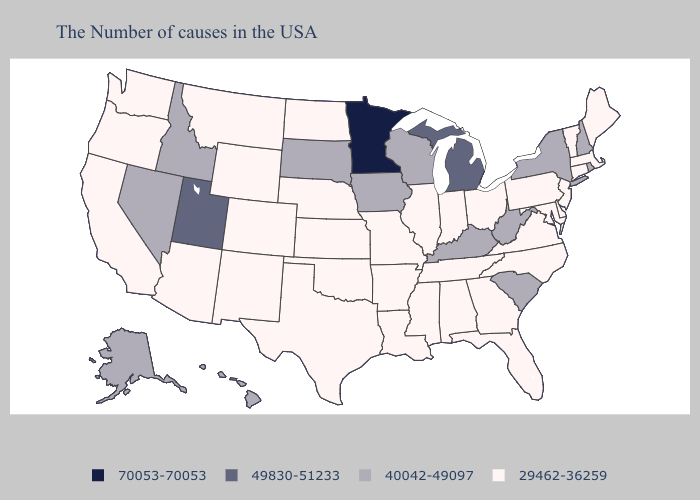Does Wisconsin have the lowest value in the MidWest?
Give a very brief answer. No. Name the states that have a value in the range 49830-51233?
Keep it brief. Michigan, Utah. Is the legend a continuous bar?
Short answer required. No. Which states hav the highest value in the MidWest?
Give a very brief answer. Minnesota. What is the value of Nebraska?
Answer briefly. 29462-36259. Which states have the highest value in the USA?
Quick response, please. Minnesota. What is the value of Colorado?
Short answer required. 29462-36259. Name the states that have a value in the range 29462-36259?
Short answer required. Maine, Massachusetts, Vermont, Connecticut, New Jersey, Delaware, Maryland, Pennsylvania, Virginia, North Carolina, Ohio, Florida, Georgia, Indiana, Alabama, Tennessee, Illinois, Mississippi, Louisiana, Missouri, Arkansas, Kansas, Nebraska, Oklahoma, Texas, North Dakota, Wyoming, Colorado, New Mexico, Montana, Arizona, California, Washington, Oregon. Does Arizona have a lower value than Idaho?
Write a very short answer. Yes. Does Iowa have the same value as Massachusetts?
Keep it brief. No. What is the value of Utah?
Write a very short answer. 49830-51233. Name the states that have a value in the range 70053-70053?
Quick response, please. Minnesota. Does Arkansas have a higher value than New York?
Quick response, please. No. 